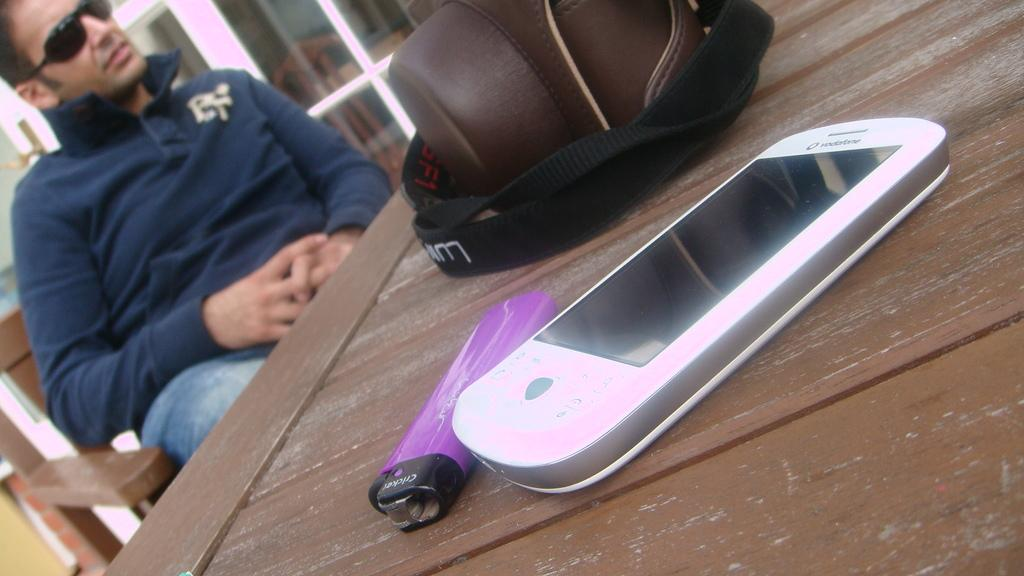Who is present in the image? There is a man in the image. What is the man wearing on his face? The man is wearing goggles. What is the man's position in the image? The man is sitting on a chair. What is the chair's location in relation to the table? The chair is in front of a table. What items can be seen on the table can be identified? There is a bag, a lighter, and a mobile on the table. What is the man's opinion about the operation of the lighter in the image? There is no indication of the man's opinion about the operation of the lighter in the image. 